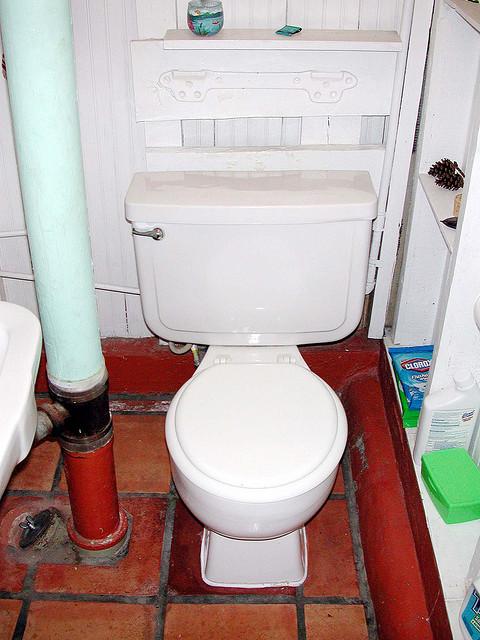What objects are to the right of the toilet?
Answer briefly. Cleaning products. Is the toilet complete?
Keep it brief. Yes. Is this toilet clean?
Short answer required. Yes. Is this a toilet?
Quick response, please. Yes. How many colors can you identify on the pipe to the left of the toilet?
Answer briefly. 3. 